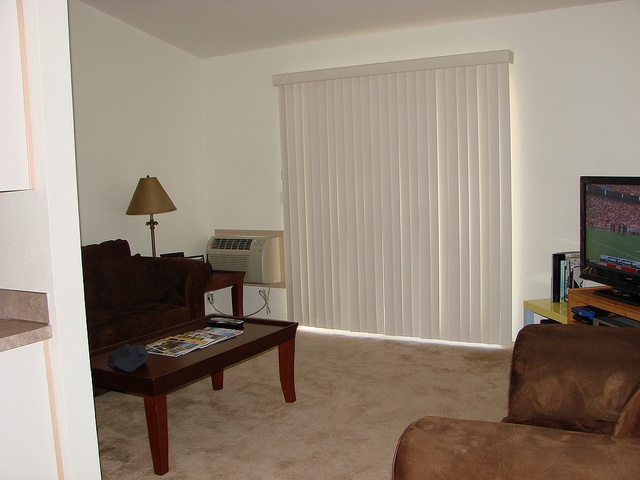Describe the objects in this image and their specific colors. I can see chair in lightgray, maroon, black, and gray tones, couch in lightgray, maroon, black, and brown tones, couch in lightgray, black, gray, and darkgray tones, tv in lightgray, black, gray, maroon, and darkgreen tones, and book in lightgray, gray, black, olive, and darkgray tones in this image. 